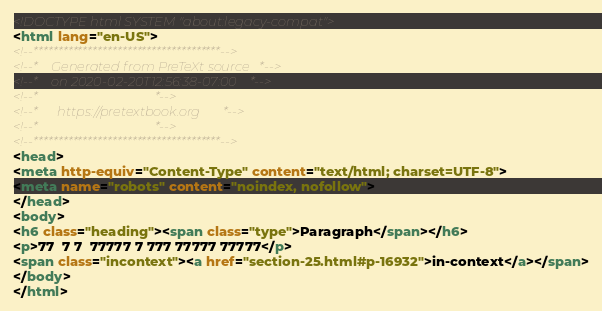<code> <loc_0><loc_0><loc_500><loc_500><_HTML_><!DOCTYPE html SYSTEM "about:legacy-compat">
<html lang="en-US">
<!--**************************************-->
<!--*    Generated from PreTeXt source   *-->
<!--*    on 2020-02-20T12:56:38-07:00    *-->
<!--*                                    *-->
<!--*      https://pretextbook.org       *-->
<!--*                                    *-->
<!--**************************************-->
<head>
<meta http-equiv="Content-Type" content="text/html; charset=UTF-8">
<meta name="robots" content="noindex, nofollow">
</head>
<body>
<h6 class="heading"><span class="type">Paragraph</span></h6>
<p>77  7 7  77777 7 777 77777 77777</p>
<span class="incontext"><a href="section-25.html#p-16932">in-context</a></span>
</body>
</html>
</code> 